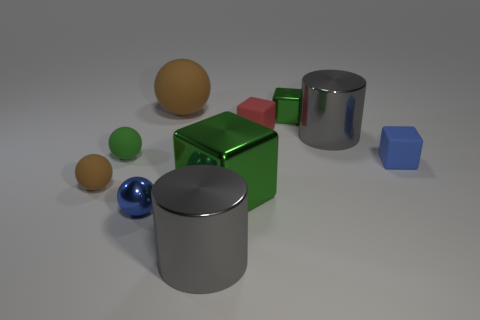Subtract all purple cylinders. How many green cubes are left? 2 Subtract all blue balls. How many balls are left? 3 Subtract all blue balls. How many balls are left? 3 Subtract 1 cubes. How many cubes are left? 3 Subtract all purple balls. Subtract all purple cylinders. How many balls are left? 4 Subtract all blocks. How many objects are left? 6 Add 3 tiny green rubber balls. How many tiny green rubber balls exist? 4 Subtract 0 gray spheres. How many objects are left? 10 Subtract all tiny brown rubber balls. Subtract all large matte objects. How many objects are left? 8 Add 9 small blue metallic spheres. How many small blue metallic spheres are left? 10 